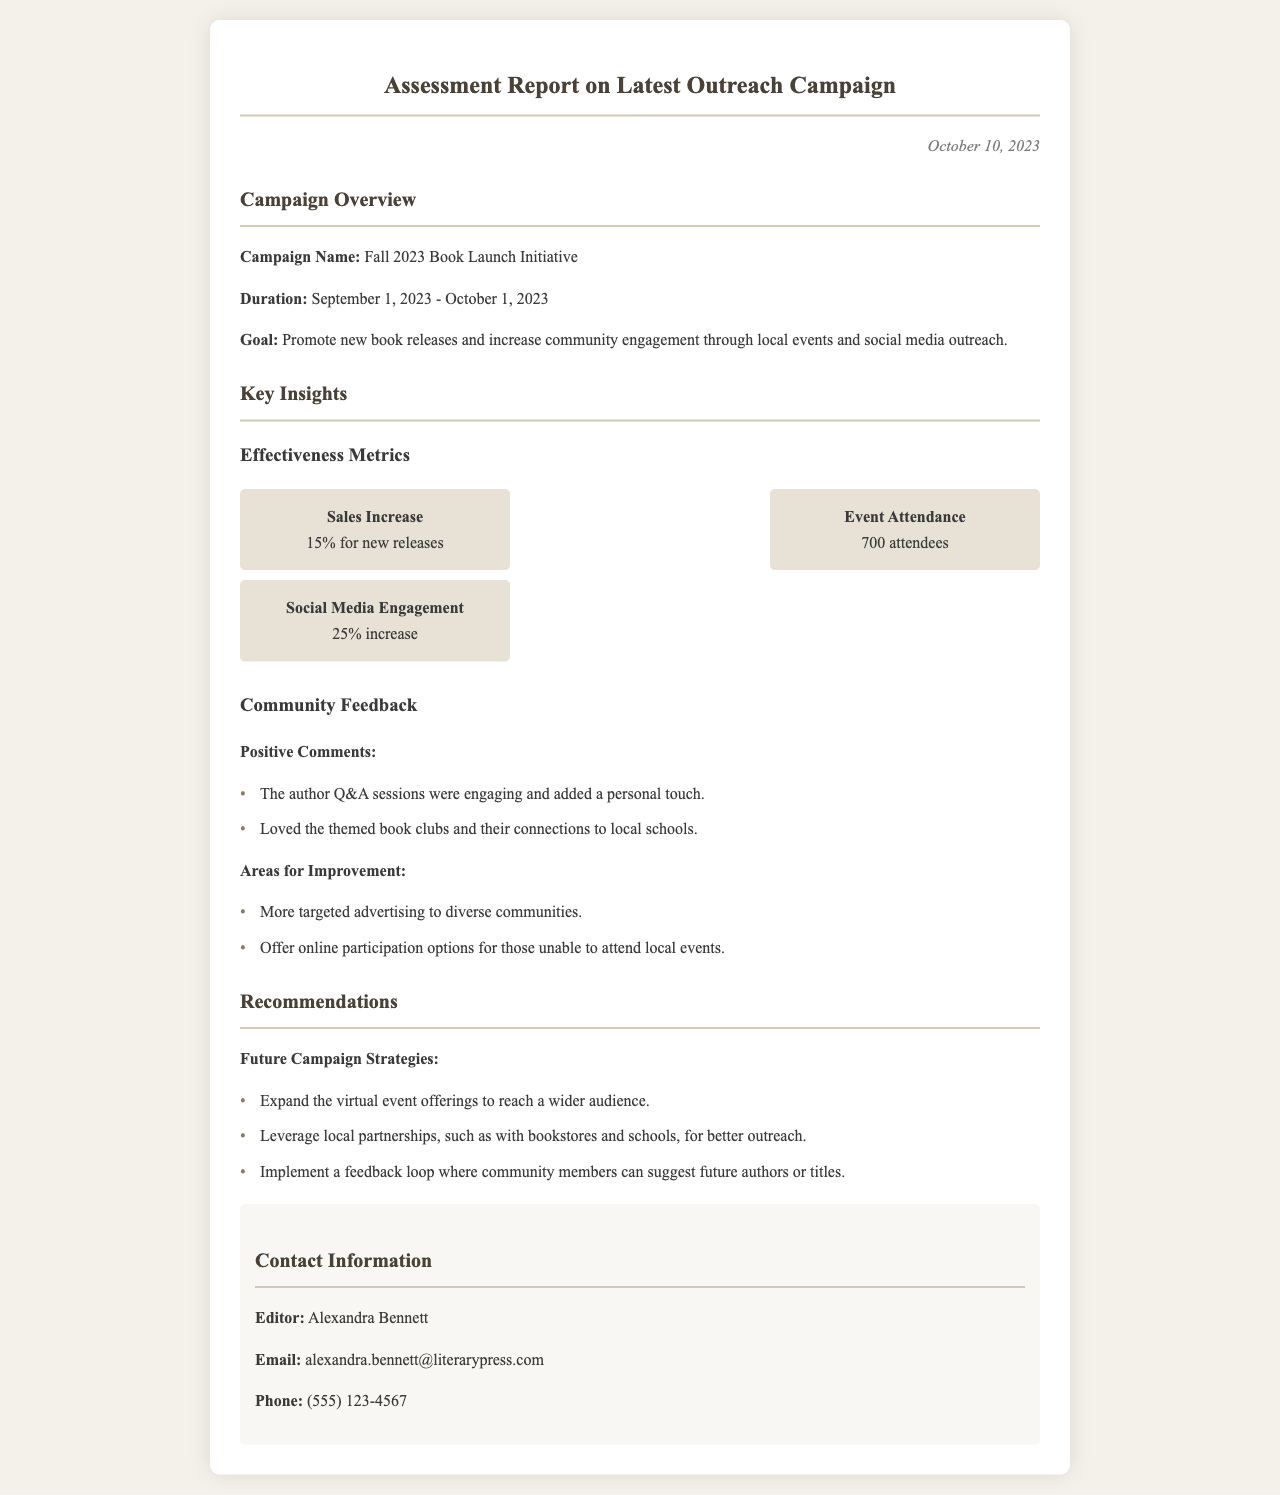What is the campaign name? The campaign name is listed in the campaign overview section of the document.
Answer: Fall 2023 Book Launch Initiative What was the duration of the campaign? The duration is specified in the campaign overview section, providing start and end dates.
Answer: September 1, 2023 - October 1, 2023 What was the sales increase percentage for new releases? The sales increase percentage is provided under effectiveness metrics.
Answer: 15% How many attendees were recorded at the events? The number of attendees is mentioned in the effectiveness metrics section of the document.
Answer: 700 attendees What type of community feedback was received regarding author Q&A sessions? Positive feedback about the author Q&A sessions is detailed in the community feedback section of the document.
Answer: Engaging and added a personal touch What recommendation is given for future campaign strategies? Recommendations for strategy are provided in the dedicated recommendations section of the document.
Answer: Expand the virtual event offerings How much was the increase in social media engagement? The percentage increase in social media engagement is included in the effectiveness metrics.
Answer: 25% increase What are the areas for improvement mentioned? Areas for improvement are listed in the community feedback section, identifying specific needs.
Answer: More targeted advertising to diverse communities Who is the editor of the report? The editor's name is mentioned in the contact information section of the document.
Answer: Alexandra Bennett 